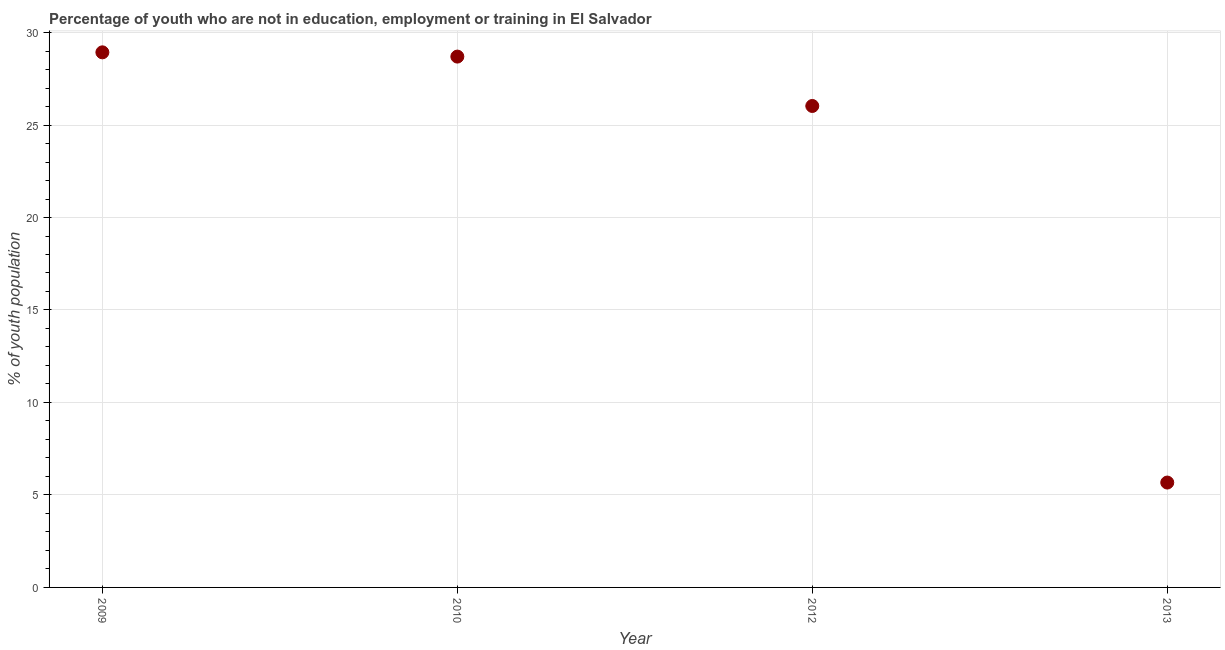What is the unemployed youth population in 2009?
Offer a terse response. 28.93. Across all years, what is the maximum unemployed youth population?
Keep it short and to the point. 28.93. Across all years, what is the minimum unemployed youth population?
Ensure brevity in your answer.  5.67. In which year was the unemployed youth population maximum?
Give a very brief answer. 2009. In which year was the unemployed youth population minimum?
Keep it short and to the point. 2013. What is the sum of the unemployed youth population?
Your response must be concise. 89.33. What is the difference between the unemployed youth population in 2009 and 2010?
Your answer should be very brief. 0.23. What is the average unemployed youth population per year?
Offer a very short reply. 22.33. What is the median unemployed youth population?
Make the answer very short. 27.37. In how many years, is the unemployed youth population greater than 10 %?
Give a very brief answer. 3. What is the ratio of the unemployed youth population in 2012 to that in 2013?
Your answer should be compact. 4.59. What is the difference between the highest and the second highest unemployed youth population?
Give a very brief answer. 0.23. Is the sum of the unemployed youth population in 2009 and 2012 greater than the maximum unemployed youth population across all years?
Ensure brevity in your answer.  Yes. What is the difference between the highest and the lowest unemployed youth population?
Your answer should be compact. 23.26. How many dotlines are there?
Your answer should be compact. 1. How many years are there in the graph?
Give a very brief answer. 4. Are the values on the major ticks of Y-axis written in scientific E-notation?
Make the answer very short. No. What is the title of the graph?
Your response must be concise. Percentage of youth who are not in education, employment or training in El Salvador. What is the label or title of the X-axis?
Ensure brevity in your answer.  Year. What is the label or title of the Y-axis?
Give a very brief answer. % of youth population. What is the % of youth population in 2009?
Ensure brevity in your answer.  28.93. What is the % of youth population in 2010?
Your answer should be compact. 28.7. What is the % of youth population in 2012?
Ensure brevity in your answer.  26.03. What is the % of youth population in 2013?
Keep it short and to the point. 5.67. What is the difference between the % of youth population in 2009 and 2010?
Provide a succinct answer. 0.23. What is the difference between the % of youth population in 2009 and 2012?
Offer a terse response. 2.9. What is the difference between the % of youth population in 2009 and 2013?
Your answer should be very brief. 23.26. What is the difference between the % of youth population in 2010 and 2012?
Provide a short and direct response. 2.67. What is the difference between the % of youth population in 2010 and 2013?
Provide a short and direct response. 23.03. What is the difference between the % of youth population in 2012 and 2013?
Your answer should be compact. 20.36. What is the ratio of the % of youth population in 2009 to that in 2010?
Offer a very short reply. 1.01. What is the ratio of the % of youth population in 2009 to that in 2012?
Make the answer very short. 1.11. What is the ratio of the % of youth population in 2009 to that in 2013?
Offer a terse response. 5.1. What is the ratio of the % of youth population in 2010 to that in 2012?
Offer a terse response. 1.1. What is the ratio of the % of youth population in 2010 to that in 2013?
Offer a very short reply. 5.06. What is the ratio of the % of youth population in 2012 to that in 2013?
Your response must be concise. 4.59. 